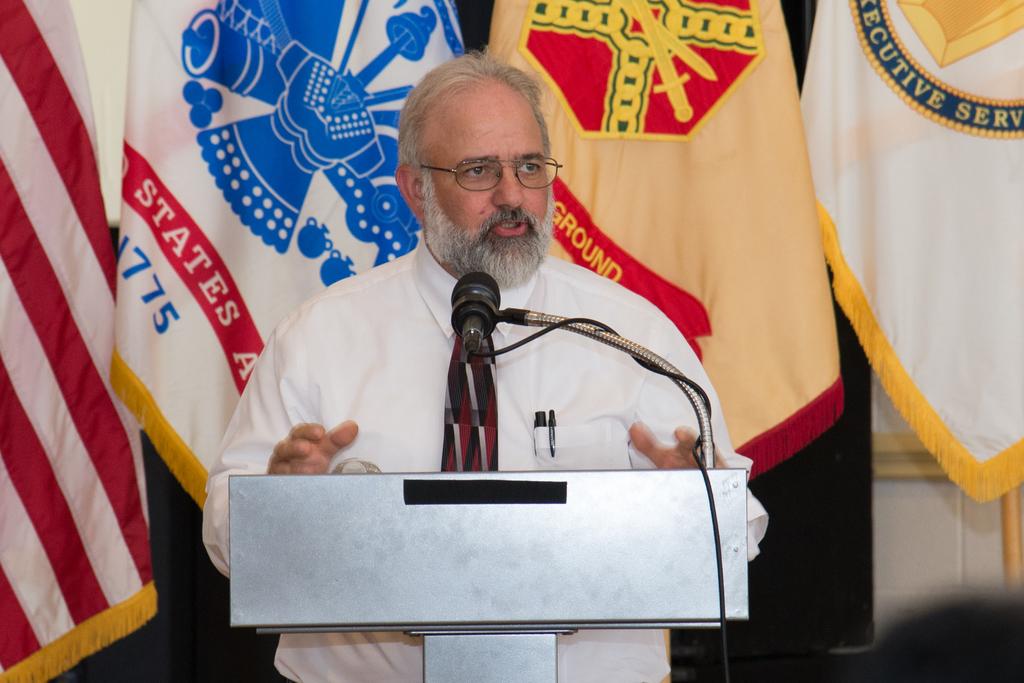What year does the white flag behind the man's right shoulder reference?
Keep it short and to the point. 1775. What word is written over the man's left shoulder in yellow?
Give a very brief answer. Ground. 